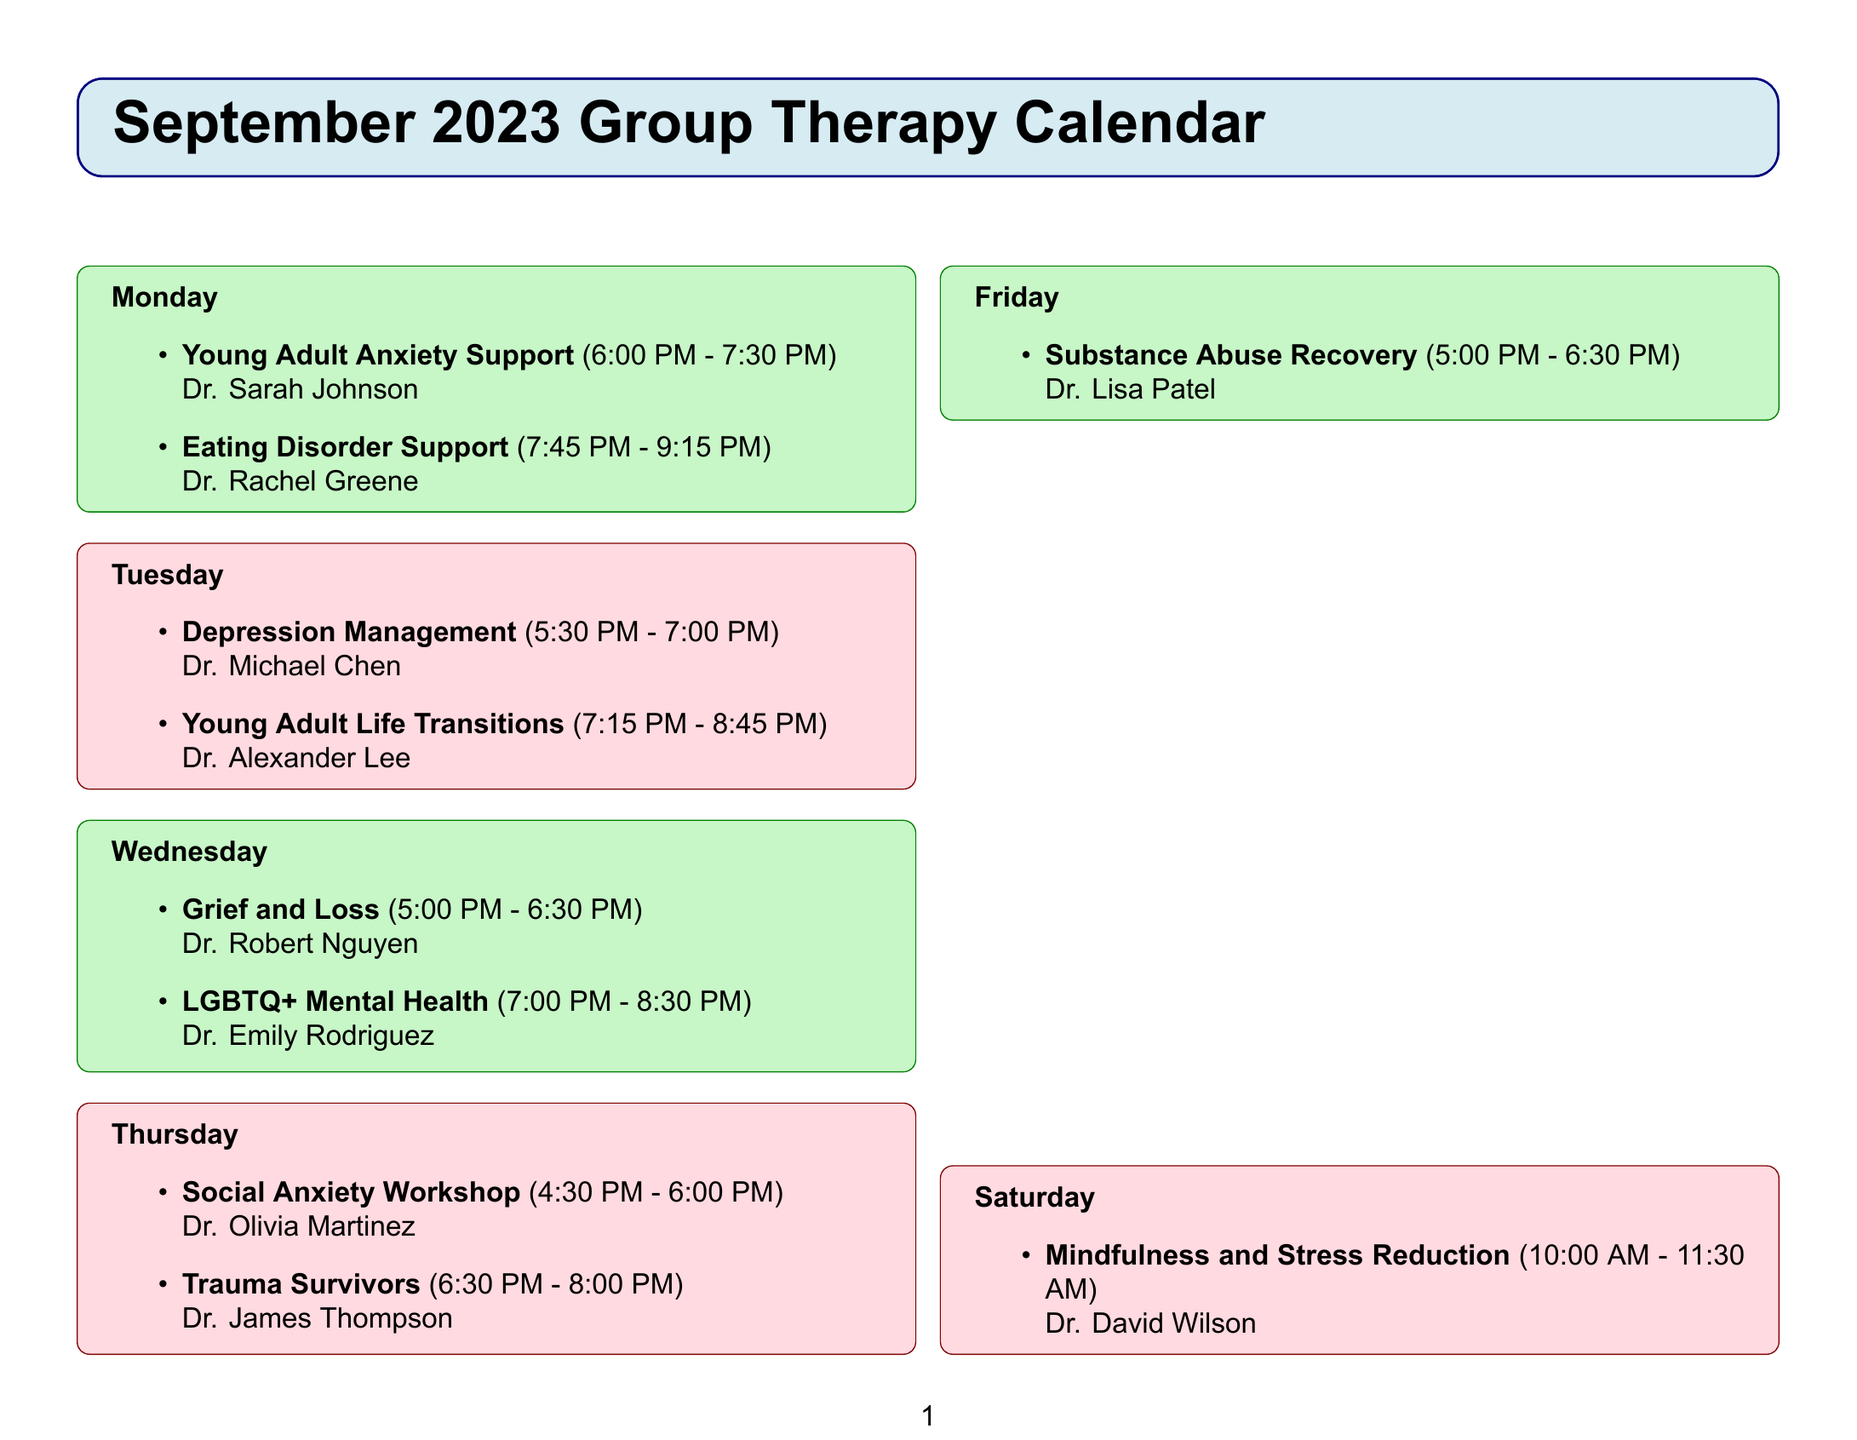What is the name of the group that meets on Mondays? The document lists two groups meeting on Mondays, which are Young Adult Anxiety Support and Eating Disorder Support.
Answer: Young Adult Anxiety Support Who facilitates the Depression Management group? The Depression Management group is led by Dr. Michael Chen as mentioned in the schedule.
Answer: Dr. Michael Chen What time does the LGBTQ+ Mental Health group start? The start time for the LGBTQ+ Mental Health group is clearly stated in the document.
Answer: 7:00 PM Which support group focuses on navigating life transitions? The document identifies a specific group tailored for those dealing with life transitions, indicating its purpose.
Answer: Young Adult Life Transitions How many support groups meet on Wednesdays? The document outlines the number of groups scheduled for Wednesdays, requiring counting from the list.
Answer: 2 What type of resources are provided in the calendar? The document includes a section for additional resources available to individuals, highlighting their purpose.
Answer: Crisis hotline, individual therapy appointments, online support community What is the location of the Mental Wellness Center? The address is detailed at the end of the document, indicating where the center is located.
Answer: 123 Harmony Street, Cityville, State 12345 On which day is the Mindfulness and Stress Reduction group held? The exact day for the Mindfulness and Stress Reduction group is specified in the schedule.
Answer: Saturday 